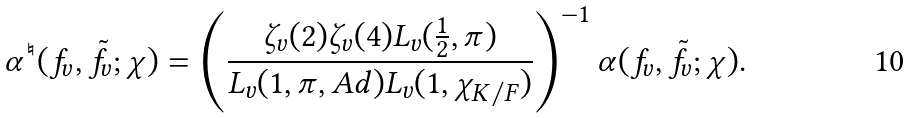<formula> <loc_0><loc_0><loc_500><loc_500>\alpha ^ { \natural } ( f _ { v } , \tilde { f } _ { v } ; \chi ) = \left ( \frac { \zeta _ { v } ( 2 ) \zeta _ { v } ( 4 ) L _ { v } ( \frac { 1 } { 2 } , \pi ) } { L _ { v } ( 1 , \pi , A d ) L _ { v } ( 1 , \chi _ { K / F } ) } \right ) ^ { - 1 } \alpha ( f _ { v } , \tilde { f } _ { v } ; \chi ) .</formula> 